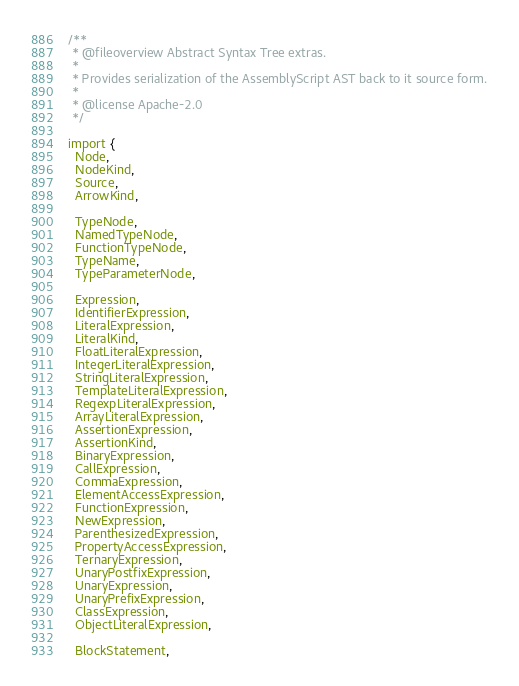Convert code to text. <code><loc_0><loc_0><loc_500><loc_500><_TypeScript_>/**
 * @fileoverview Abstract Syntax Tree extras.
 *
 * Provides serialization of the AssemblyScript AST back to it source form.
 *
 * @license Apache-2.0
 */

import {
  Node,
  NodeKind,
  Source,
  ArrowKind,

  TypeNode,
  NamedTypeNode,
  FunctionTypeNode,
  TypeName,
  TypeParameterNode,

  Expression,
  IdentifierExpression,
  LiteralExpression,
  LiteralKind,
  FloatLiteralExpression,
  IntegerLiteralExpression,
  StringLiteralExpression,
  TemplateLiteralExpression,
  RegexpLiteralExpression,
  ArrayLiteralExpression,
  AssertionExpression,
  AssertionKind,
  BinaryExpression,
  CallExpression,
  CommaExpression,
  ElementAccessExpression,
  FunctionExpression,
  NewExpression,
  ParenthesizedExpression,
  PropertyAccessExpression,
  TernaryExpression,
  UnaryPostfixExpression,
  UnaryExpression,
  UnaryPrefixExpression,
  ClassExpression,
  ObjectLiteralExpression,

  BlockStatement,</code> 